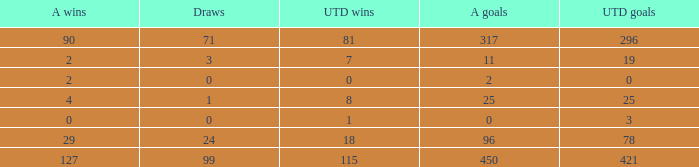What is the total number of U Wins, when Alianza Goals is "0", and when U Goals is greater than 3? 0.0. 